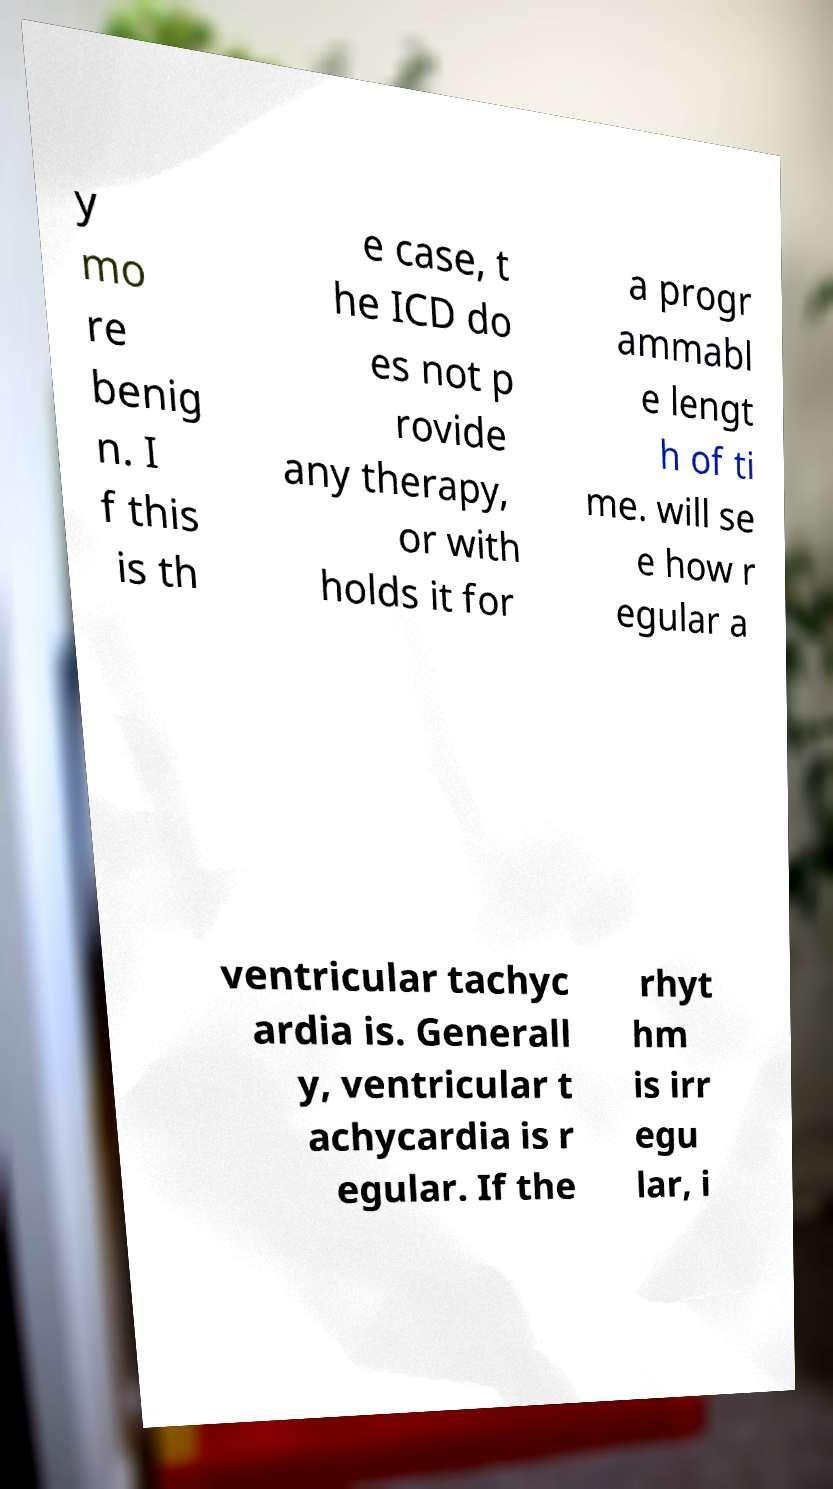Can you accurately transcribe the text from the provided image for me? y mo re benig n. I f this is th e case, t he ICD do es not p rovide any therapy, or with holds it for a progr ammabl e lengt h of ti me. will se e how r egular a ventricular tachyc ardia is. Generall y, ventricular t achycardia is r egular. If the rhyt hm is irr egu lar, i 